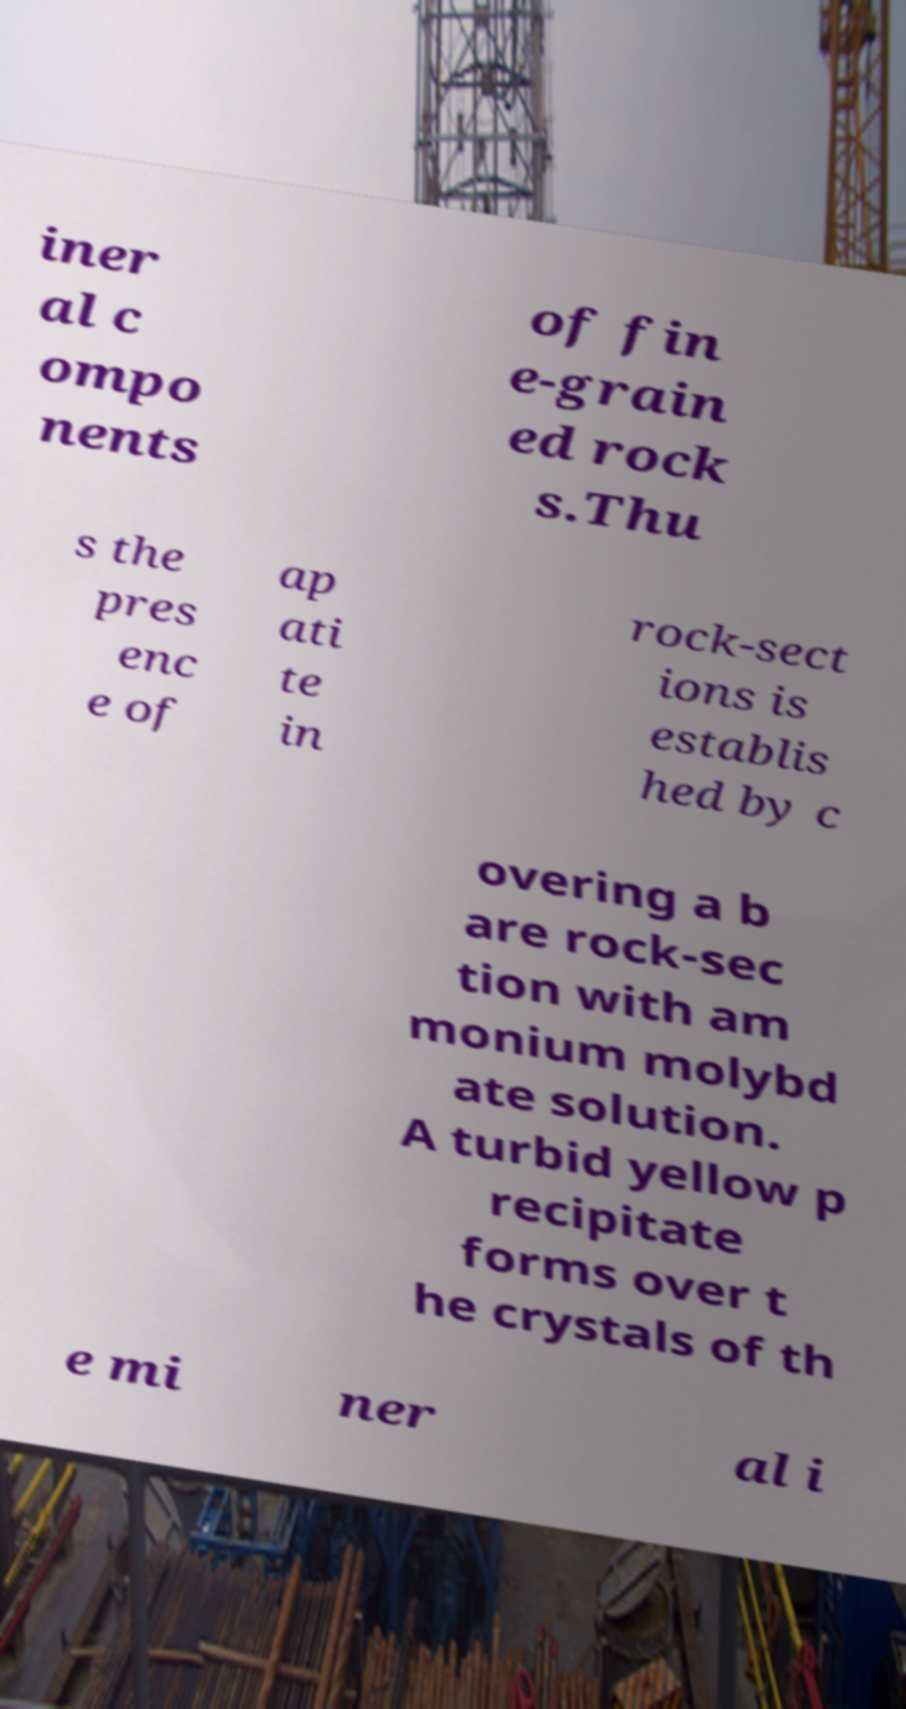Could you extract and type out the text from this image? iner al c ompo nents of fin e-grain ed rock s.Thu s the pres enc e of ap ati te in rock-sect ions is establis hed by c overing a b are rock-sec tion with am monium molybd ate solution. A turbid yellow p recipitate forms over t he crystals of th e mi ner al i 